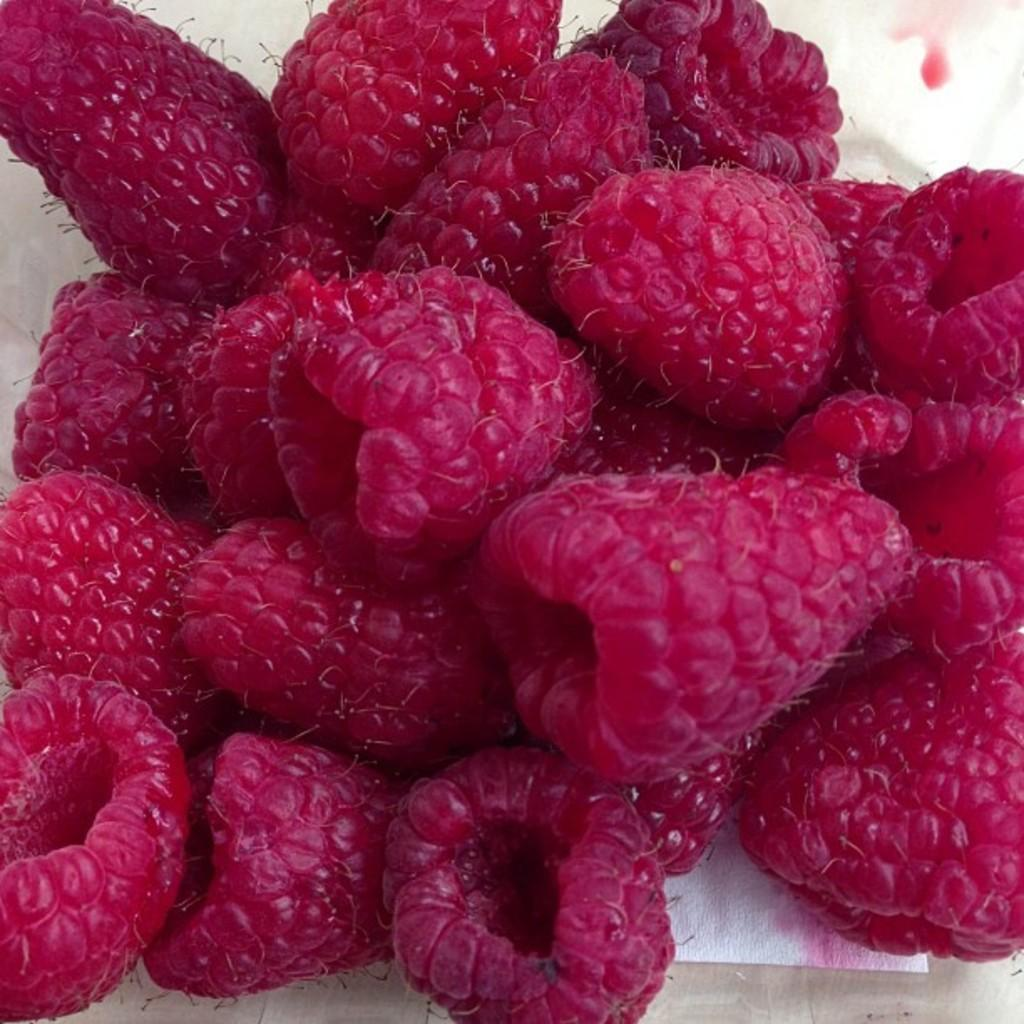What type of fruit is present in the image? There are berries in the image. What is the color of the surface on which the berries are placed? The berries are on a white surface. What is the reason for the drain being clogged in the image? There is no drain present in the image, so it is not possible to determine the reason for any clogging. 